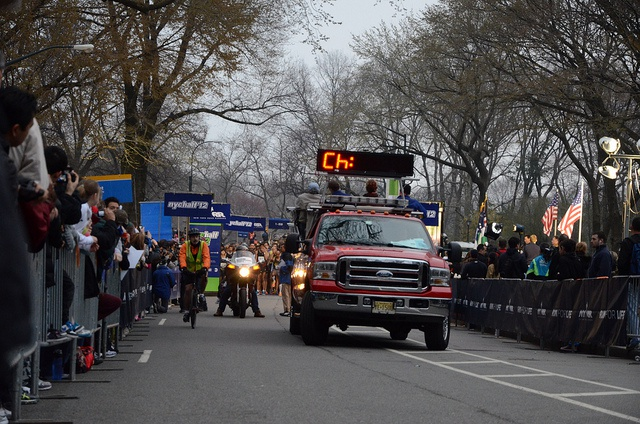Describe the objects in this image and their specific colors. I can see truck in black, gray, darkgray, and maroon tones, people in black, gray, maroon, and navy tones, people in black, gray, and maroon tones, people in black, gray, and darkgray tones, and people in black, olive, maroon, and red tones in this image. 